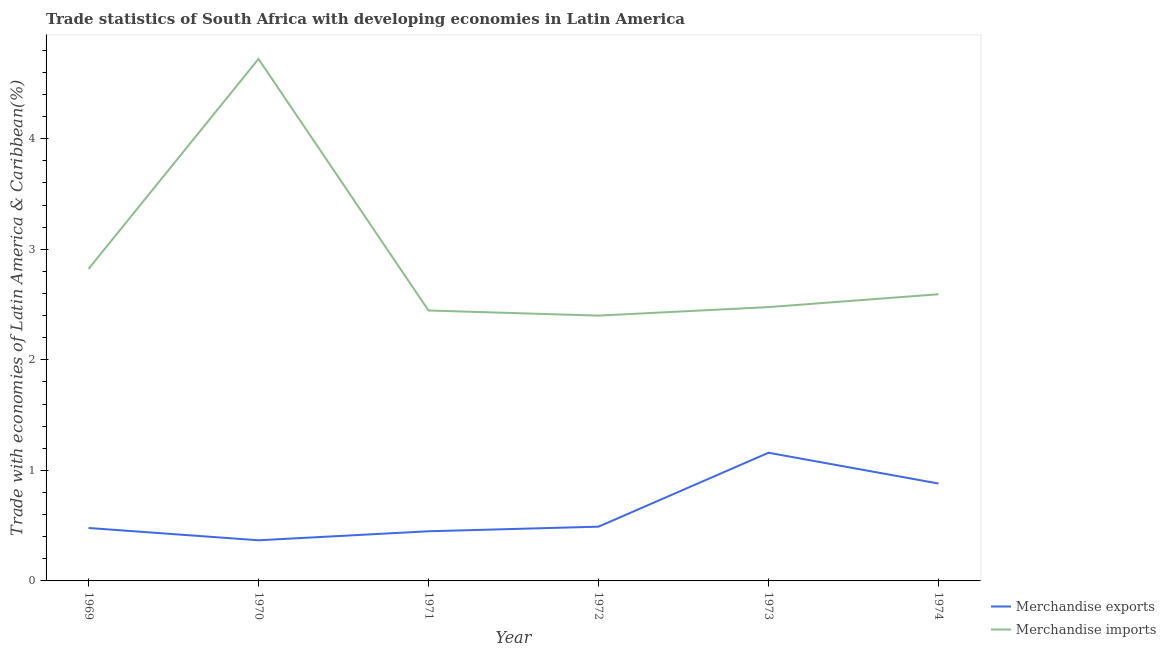Does the line corresponding to merchandise imports intersect with the line corresponding to merchandise exports?
Keep it short and to the point. No. What is the merchandise exports in 1971?
Provide a short and direct response. 0.45. Across all years, what is the maximum merchandise imports?
Your answer should be very brief. 4.72. Across all years, what is the minimum merchandise exports?
Keep it short and to the point. 0.37. In which year was the merchandise exports maximum?
Ensure brevity in your answer.  1973. What is the total merchandise imports in the graph?
Give a very brief answer. 17.46. What is the difference between the merchandise exports in 1971 and that in 1974?
Your answer should be compact. -0.43. What is the difference between the merchandise exports in 1974 and the merchandise imports in 1969?
Provide a short and direct response. -1.94. What is the average merchandise exports per year?
Provide a short and direct response. 0.64. In the year 1974, what is the difference between the merchandise exports and merchandise imports?
Offer a terse response. -1.71. In how many years, is the merchandise exports greater than 1.8 %?
Keep it short and to the point. 0. What is the ratio of the merchandise exports in 1971 to that in 1973?
Make the answer very short. 0.39. Is the merchandise exports in 1969 less than that in 1972?
Provide a short and direct response. Yes. What is the difference between the highest and the second highest merchandise imports?
Your response must be concise. 1.9. What is the difference between the highest and the lowest merchandise exports?
Your response must be concise. 0.79. Is the sum of the merchandise exports in 1969 and 1972 greater than the maximum merchandise imports across all years?
Your response must be concise. No. How many years are there in the graph?
Keep it short and to the point. 6. Does the graph contain any zero values?
Keep it short and to the point. No. How many legend labels are there?
Your answer should be very brief. 2. How are the legend labels stacked?
Your answer should be compact. Vertical. What is the title of the graph?
Provide a succinct answer. Trade statistics of South Africa with developing economies in Latin America. Does "Electricity" appear as one of the legend labels in the graph?
Keep it short and to the point. No. What is the label or title of the X-axis?
Your response must be concise. Year. What is the label or title of the Y-axis?
Provide a succinct answer. Trade with economies of Latin America & Caribbean(%). What is the Trade with economies of Latin America & Caribbean(%) in Merchandise exports in 1969?
Keep it short and to the point. 0.48. What is the Trade with economies of Latin America & Caribbean(%) in Merchandise imports in 1969?
Your response must be concise. 2.82. What is the Trade with economies of Latin America & Caribbean(%) of Merchandise exports in 1970?
Ensure brevity in your answer.  0.37. What is the Trade with economies of Latin America & Caribbean(%) of Merchandise imports in 1970?
Provide a succinct answer. 4.72. What is the Trade with economies of Latin America & Caribbean(%) of Merchandise exports in 1971?
Provide a short and direct response. 0.45. What is the Trade with economies of Latin America & Caribbean(%) of Merchandise imports in 1971?
Provide a short and direct response. 2.45. What is the Trade with economies of Latin America & Caribbean(%) of Merchandise exports in 1972?
Offer a terse response. 0.49. What is the Trade with economies of Latin America & Caribbean(%) of Merchandise imports in 1972?
Make the answer very short. 2.4. What is the Trade with economies of Latin America & Caribbean(%) in Merchandise exports in 1973?
Make the answer very short. 1.16. What is the Trade with economies of Latin America & Caribbean(%) in Merchandise imports in 1973?
Ensure brevity in your answer.  2.48. What is the Trade with economies of Latin America & Caribbean(%) in Merchandise exports in 1974?
Your response must be concise. 0.88. What is the Trade with economies of Latin America & Caribbean(%) in Merchandise imports in 1974?
Provide a succinct answer. 2.59. Across all years, what is the maximum Trade with economies of Latin America & Caribbean(%) of Merchandise exports?
Offer a very short reply. 1.16. Across all years, what is the maximum Trade with economies of Latin America & Caribbean(%) in Merchandise imports?
Give a very brief answer. 4.72. Across all years, what is the minimum Trade with economies of Latin America & Caribbean(%) of Merchandise exports?
Keep it short and to the point. 0.37. Across all years, what is the minimum Trade with economies of Latin America & Caribbean(%) in Merchandise imports?
Ensure brevity in your answer.  2.4. What is the total Trade with economies of Latin America & Caribbean(%) of Merchandise exports in the graph?
Offer a terse response. 3.83. What is the total Trade with economies of Latin America & Caribbean(%) in Merchandise imports in the graph?
Offer a terse response. 17.46. What is the difference between the Trade with economies of Latin America & Caribbean(%) in Merchandise exports in 1969 and that in 1970?
Provide a short and direct response. 0.11. What is the difference between the Trade with economies of Latin America & Caribbean(%) of Merchandise imports in 1969 and that in 1970?
Give a very brief answer. -1.9. What is the difference between the Trade with economies of Latin America & Caribbean(%) in Merchandise exports in 1969 and that in 1971?
Offer a terse response. 0.03. What is the difference between the Trade with economies of Latin America & Caribbean(%) of Merchandise imports in 1969 and that in 1971?
Your response must be concise. 0.38. What is the difference between the Trade with economies of Latin America & Caribbean(%) of Merchandise exports in 1969 and that in 1972?
Provide a succinct answer. -0.01. What is the difference between the Trade with economies of Latin America & Caribbean(%) of Merchandise imports in 1969 and that in 1972?
Offer a very short reply. 0.42. What is the difference between the Trade with economies of Latin America & Caribbean(%) of Merchandise exports in 1969 and that in 1973?
Offer a terse response. -0.68. What is the difference between the Trade with economies of Latin America & Caribbean(%) in Merchandise imports in 1969 and that in 1973?
Provide a succinct answer. 0.35. What is the difference between the Trade with economies of Latin America & Caribbean(%) of Merchandise exports in 1969 and that in 1974?
Provide a succinct answer. -0.4. What is the difference between the Trade with economies of Latin America & Caribbean(%) of Merchandise imports in 1969 and that in 1974?
Provide a succinct answer. 0.23. What is the difference between the Trade with economies of Latin America & Caribbean(%) in Merchandise exports in 1970 and that in 1971?
Offer a terse response. -0.08. What is the difference between the Trade with economies of Latin America & Caribbean(%) in Merchandise imports in 1970 and that in 1971?
Provide a succinct answer. 2.28. What is the difference between the Trade with economies of Latin America & Caribbean(%) in Merchandise exports in 1970 and that in 1972?
Provide a succinct answer. -0.12. What is the difference between the Trade with economies of Latin America & Caribbean(%) in Merchandise imports in 1970 and that in 1972?
Keep it short and to the point. 2.32. What is the difference between the Trade with economies of Latin America & Caribbean(%) of Merchandise exports in 1970 and that in 1973?
Keep it short and to the point. -0.79. What is the difference between the Trade with economies of Latin America & Caribbean(%) in Merchandise imports in 1970 and that in 1973?
Keep it short and to the point. 2.24. What is the difference between the Trade with economies of Latin America & Caribbean(%) of Merchandise exports in 1970 and that in 1974?
Make the answer very short. -0.51. What is the difference between the Trade with economies of Latin America & Caribbean(%) in Merchandise imports in 1970 and that in 1974?
Ensure brevity in your answer.  2.13. What is the difference between the Trade with economies of Latin America & Caribbean(%) of Merchandise exports in 1971 and that in 1972?
Your answer should be very brief. -0.04. What is the difference between the Trade with economies of Latin America & Caribbean(%) in Merchandise imports in 1971 and that in 1972?
Keep it short and to the point. 0.05. What is the difference between the Trade with economies of Latin America & Caribbean(%) of Merchandise exports in 1971 and that in 1973?
Your answer should be very brief. -0.71. What is the difference between the Trade with economies of Latin America & Caribbean(%) of Merchandise imports in 1971 and that in 1973?
Your answer should be compact. -0.03. What is the difference between the Trade with economies of Latin America & Caribbean(%) in Merchandise exports in 1971 and that in 1974?
Offer a terse response. -0.43. What is the difference between the Trade with economies of Latin America & Caribbean(%) in Merchandise imports in 1971 and that in 1974?
Offer a terse response. -0.15. What is the difference between the Trade with economies of Latin America & Caribbean(%) in Merchandise exports in 1972 and that in 1973?
Ensure brevity in your answer.  -0.67. What is the difference between the Trade with economies of Latin America & Caribbean(%) in Merchandise imports in 1972 and that in 1973?
Your answer should be compact. -0.08. What is the difference between the Trade with economies of Latin America & Caribbean(%) of Merchandise exports in 1972 and that in 1974?
Your response must be concise. -0.39. What is the difference between the Trade with economies of Latin America & Caribbean(%) in Merchandise imports in 1972 and that in 1974?
Your answer should be very brief. -0.19. What is the difference between the Trade with economies of Latin America & Caribbean(%) in Merchandise exports in 1973 and that in 1974?
Your answer should be compact. 0.28. What is the difference between the Trade with economies of Latin America & Caribbean(%) of Merchandise imports in 1973 and that in 1974?
Make the answer very short. -0.12. What is the difference between the Trade with economies of Latin America & Caribbean(%) of Merchandise exports in 1969 and the Trade with economies of Latin America & Caribbean(%) of Merchandise imports in 1970?
Give a very brief answer. -4.24. What is the difference between the Trade with economies of Latin America & Caribbean(%) in Merchandise exports in 1969 and the Trade with economies of Latin America & Caribbean(%) in Merchandise imports in 1971?
Your answer should be compact. -1.97. What is the difference between the Trade with economies of Latin America & Caribbean(%) of Merchandise exports in 1969 and the Trade with economies of Latin America & Caribbean(%) of Merchandise imports in 1972?
Make the answer very short. -1.92. What is the difference between the Trade with economies of Latin America & Caribbean(%) in Merchandise exports in 1969 and the Trade with economies of Latin America & Caribbean(%) in Merchandise imports in 1973?
Your answer should be compact. -2. What is the difference between the Trade with economies of Latin America & Caribbean(%) in Merchandise exports in 1969 and the Trade with economies of Latin America & Caribbean(%) in Merchandise imports in 1974?
Provide a short and direct response. -2.11. What is the difference between the Trade with economies of Latin America & Caribbean(%) of Merchandise exports in 1970 and the Trade with economies of Latin America & Caribbean(%) of Merchandise imports in 1971?
Provide a succinct answer. -2.08. What is the difference between the Trade with economies of Latin America & Caribbean(%) of Merchandise exports in 1970 and the Trade with economies of Latin America & Caribbean(%) of Merchandise imports in 1972?
Keep it short and to the point. -2.03. What is the difference between the Trade with economies of Latin America & Caribbean(%) of Merchandise exports in 1970 and the Trade with economies of Latin America & Caribbean(%) of Merchandise imports in 1973?
Your response must be concise. -2.11. What is the difference between the Trade with economies of Latin America & Caribbean(%) in Merchandise exports in 1970 and the Trade with economies of Latin America & Caribbean(%) in Merchandise imports in 1974?
Ensure brevity in your answer.  -2.23. What is the difference between the Trade with economies of Latin America & Caribbean(%) of Merchandise exports in 1971 and the Trade with economies of Latin America & Caribbean(%) of Merchandise imports in 1972?
Offer a very short reply. -1.95. What is the difference between the Trade with economies of Latin America & Caribbean(%) of Merchandise exports in 1971 and the Trade with economies of Latin America & Caribbean(%) of Merchandise imports in 1973?
Make the answer very short. -2.03. What is the difference between the Trade with economies of Latin America & Caribbean(%) in Merchandise exports in 1971 and the Trade with economies of Latin America & Caribbean(%) in Merchandise imports in 1974?
Your response must be concise. -2.14. What is the difference between the Trade with economies of Latin America & Caribbean(%) in Merchandise exports in 1972 and the Trade with economies of Latin America & Caribbean(%) in Merchandise imports in 1973?
Give a very brief answer. -1.99. What is the difference between the Trade with economies of Latin America & Caribbean(%) in Merchandise exports in 1972 and the Trade with economies of Latin America & Caribbean(%) in Merchandise imports in 1974?
Offer a very short reply. -2.1. What is the difference between the Trade with economies of Latin America & Caribbean(%) of Merchandise exports in 1973 and the Trade with economies of Latin America & Caribbean(%) of Merchandise imports in 1974?
Your response must be concise. -1.43. What is the average Trade with economies of Latin America & Caribbean(%) of Merchandise exports per year?
Make the answer very short. 0.64. What is the average Trade with economies of Latin America & Caribbean(%) in Merchandise imports per year?
Offer a terse response. 2.91. In the year 1969, what is the difference between the Trade with economies of Latin America & Caribbean(%) in Merchandise exports and Trade with economies of Latin America & Caribbean(%) in Merchandise imports?
Keep it short and to the point. -2.34. In the year 1970, what is the difference between the Trade with economies of Latin America & Caribbean(%) of Merchandise exports and Trade with economies of Latin America & Caribbean(%) of Merchandise imports?
Your answer should be very brief. -4.35. In the year 1971, what is the difference between the Trade with economies of Latin America & Caribbean(%) of Merchandise exports and Trade with economies of Latin America & Caribbean(%) of Merchandise imports?
Your response must be concise. -2. In the year 1972, what is the difference between the Trade with economies of Latin America & Caribbean(%) in Merchandise exports and Trade with economies of Latin America & Caribbean(%) in Merchandise imports?
Provide a short and direct response. -1.91. In the year 1973, what is the difference between the Trade with economies of Latin America & Caribbean(%) of Merchandise exports and Trade with economies of Latin America & Caribbean(%) of Merchandise imports?
Ensure brevity in your answer.  -1.32. In the year 1974, what is the difference between the Trade with economies of Latin America & Caribbean(%) of Merchandise exports and Trade with economies of Latin America & Caribbean(%) of Merchandise imports?
Provide a succinct answer. -1.71. What is the ratio of the Trade with economies of Latin America & Caribbean(%) in Merchandise exports in 1969 to that in 1970?
Your answer should be compact. 1.3. What is the ratio of the Trade with economies of Latin America & Caribbean(%) in Merchandise imports in 1969 to that in 1970?
Your answer should be very brief. 0.6. What is the ratio of the Trade with economies of Latin America & Caribbean(%) of Merchandise exports in 1969 to that in 1971?
Make the answer very short. 1.07. What is the ratio of the Trade with economies of Latin America & Caribbean(%) of Merchandise imports in 1969 to that in 1971?
Your answer should be compact. 1.15. What is the ratio of the Trade with economies of Latin America & Caribbean(%) in Merchandise exports in 1969 to that in 1972?
Ensure brevity in your answer.  0.98. What is the ratio of the Trade with economies of Latin America & Caribbean(%) of Merchandise imports in 1969 to that in 1972?
Ensure brevity in your answer.  1.18. What is the ratio of the Trade with economies of Latin America & Caribbean(%) in Merchandise exports in 1969 to that in 1973?
Keep it short and to the point. 0.41. What is the ratio of the Trade with economies of Latin America & Caribbean(%) of Merchandise imports in 1969 to that in 1973?
Make the answer very short. 1.14. What is the ratio of the Trade with economies of Latin America & Caribbean(%) in Merchandise exports in 1969 to that in 1974?
Your response must be concise. 0.54. What is the ratio of the Trade with economies of Latin America & Caribbean(%) of Merchandise imports in 1969 to that in 1974?
Keep it short and to the point. 1.09. What is the ratio of the Trade with economies of Latin America & Caribbean(%) in Merchandise exports in 1970 to that in 1971?
Ensure brevity in your answer.  0.82. What is the ratio of the Trade with economies of Latin America & Caribbean(%) in Merchandise imports in 1970 to that in 1971?
Keep it short and to the point. 1.93. What is the ratio of the Trade with economies of Latin America & Caribbean(%) of Merchandise exports in 1970 to that in 1972?
Provide a short and direct response. 0.75. What is the ratio of the Trade with economies of Latin America & Caribbean(%) in Merchandise imports in 1970 to that in 1972?
Make the answer very short. 1.97. What is the ratio of the Trade with economies of Latin America & Caribbean(%) in Merchandise exports in 1970 to that in 1973?
Provide a short and direct response. 0.32. What is the ratio of the Trade with economies of Latin America & Caribbean(%) of Merchandise imports in 1970 to that in 1973?
Offer a very short reply. 1.91. What is the ratio of the Trade with economies of Latin America & Caribbean(%) of Merchandise exports in 1970 to that in 1974?
Provide a succinct answer. 0.42. What is the ratio of the Trade with economies of Latin America & Caribbean(%) in Merchandise imports in 1970 to that in 1974?
Your answer should be very brief. 1.82. What is the ratio of the Trade with economies of Latin America & Caribbean(%) of Merchandise exports in 1971 to that in 1972?
Provide a succinct answer. 0.92. What is the ratio of the Trade with economies of Latin America & Caribbean(%) in Merchandise imports in 1971 to that in 1972?
Your answer should be very brief. 1.02. What is the ratio of the Trade with economies of Latin America & Caribbean(%) in Merchandise exports in 1971 to that in 1973?
Your response must be concise. 0.39. What is the ratio of the Trade with economies of Latin America & Caribbean(%) in Merchandise imports in 1971 to that in 1973?
Ensure brevity in your answer.  0.99. What is the ratio of the Trade with economies of Latin America & Caribbean(%) of Merchandise exports in 1971 to that in 1974?
Keep it short and to the point. 0.51. What is the ratio of the Trade with economies of Latin America & Caribbean(%) in Merchandise imports in 1971 to that in 1974?
Your answer should be very brief. 0.94. What is the ratio of the Trade with economies of Latin America & Caribbean(%) in Merchandise exports in 1972 to that in 1973?
Ensure brevity in your answer.  0.42. What is the ratio of the Trade with economies of Latin America & Caribbean(%) in Merchandise imports in 1972 to that in 1973?
Provide a short and direct response. 0.97. What is the ratio of the Trade with economies of Latin America & Caribbean(%) in Merchandise exports in 1972 to that in 1974?
Your answer should be compact. 0.56. What is the ratio of the Trade with economies of Latin America & Caribbean(%) of Merchandise imports in 1972 to that in 1974?
Give a very brief answer. 0.93. What is the ratio of the Trade with economies of Latin America & Caribbean(%) in Merchandise exports in 1973 to that in 1974?
Keep it short and to the point. 1.32. What is the ratio of the Trade with economies of Latin America & Caribbean(%) in Merchandise imports in 1973 to that in 1974?
Your answer should be compact. 0.96. What is the difference between the highest and the second highest Trade with economies of Latin America & Caribbean(%) of Merchandise exports?
Ensure brevity in your answer.  0.28. What is the difference between the highest and the second highest Trade with economies of Latin America & Caribbean(%) in Merchandise imports?
Your answer should be compact. 1.9. What is the difference between the highest and the lowest Trade with economies of Latin America & Caribbean(%) of Merchandise exports?
Your response must be concise. 0.79. What is the difference between the highest and the lowest Trade with economies of Latin America & Caribbean(%) in Merchandise imports?
Offer a very short reply. 2.32. 